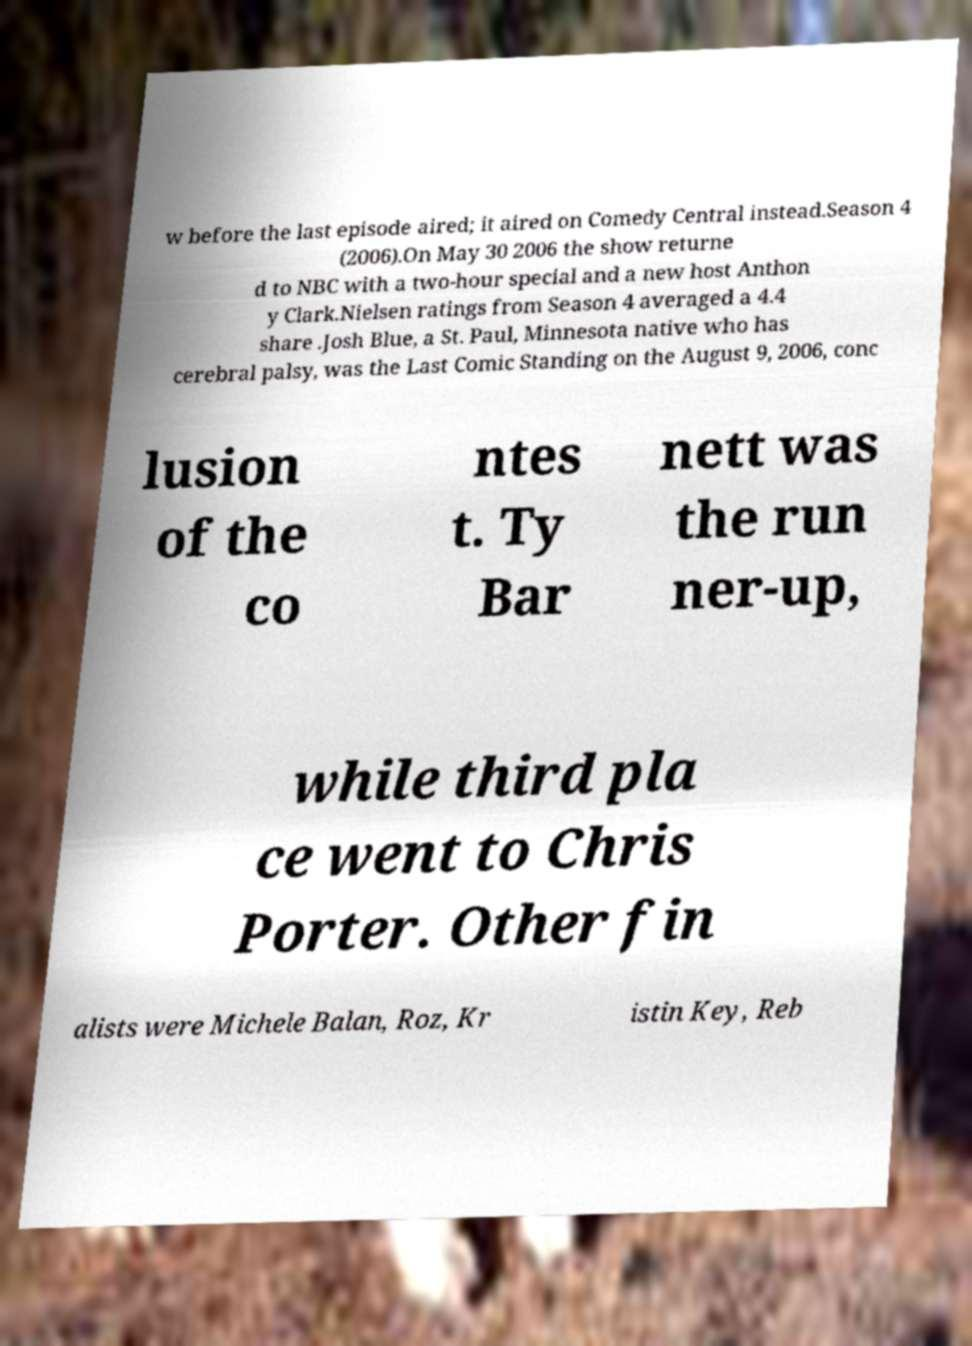Can you accurately transcribe the text from the provided image for me? w before the last episode aired; it aired on Comedy Central instead.Season 4 (2006).On May 30 2006 the show returne d to NBC with a two-hour special and a new host Anthon y Clark.Nielsen ratings from Season 4 averaged a 4.4 share .Josh Blue, a St. Paul, Minnesota native who has cerebral palsy, was the Last Comic Standing on the August 9, 2006, conc lusion of the co ntes t. Ty Bar nett was the run ner-up, while third pla ce went to Chris Porter. Other fin alists were Michele Balan, Roz, Kr istin Key, Reb 